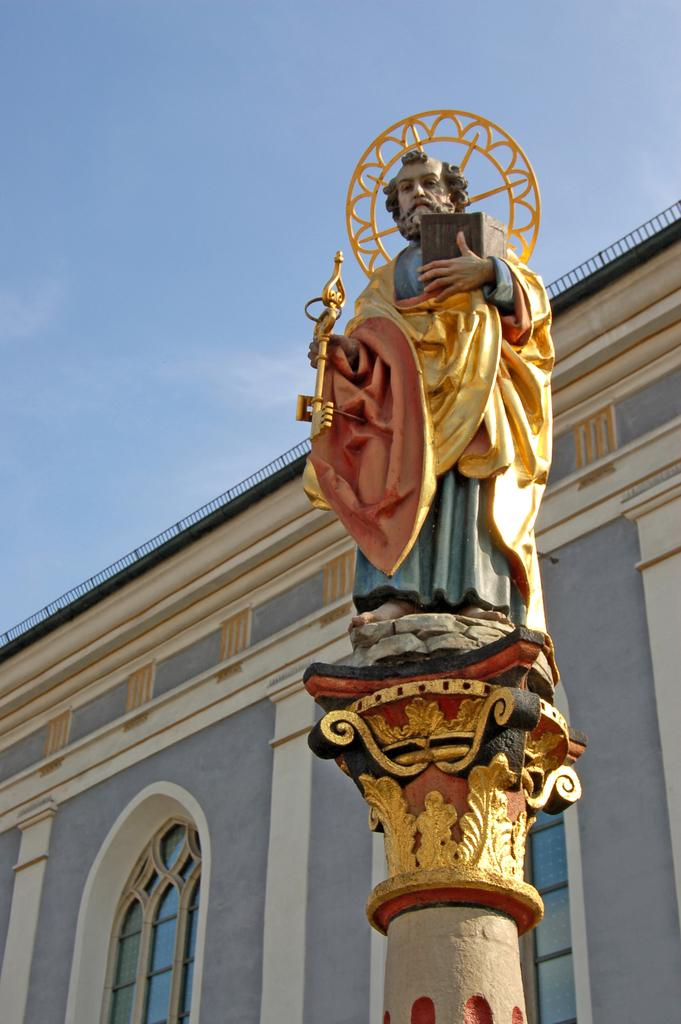What is the main subject in the image? There is a statue in the image. What type of structure can be seen in the image? There is a building with windows in the image. What can be seen in the background of the image? The sky is visible in the background of the image. What type of scarf is the statue wearing in the image? The statue is not wearing a scarf in the image, as statues are typically made of inanimate materials like stone or metal. 